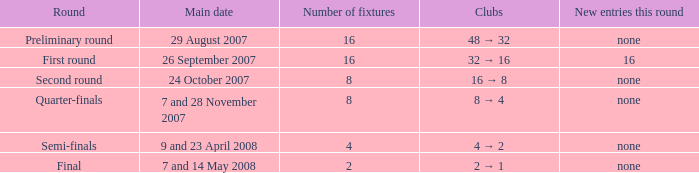What is the New entries this round when the round is the semi-finals? None. 